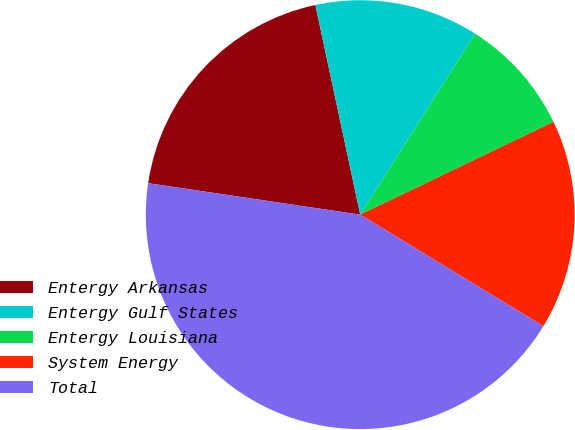Convert chart. <chart><loc_0><loc_0><loc_500><loc_500><pie_chart><fcel>Entergy Arkansas<fcel>Entergy Gulf States<fcel>Entergy Louisiana<fcel>System Energy<fcel>Total<nl><fcel>19.3%<fcel>12.35%<fcel>8.88%<fcel>15.83%<fcel>43.64%<nl></chart> 